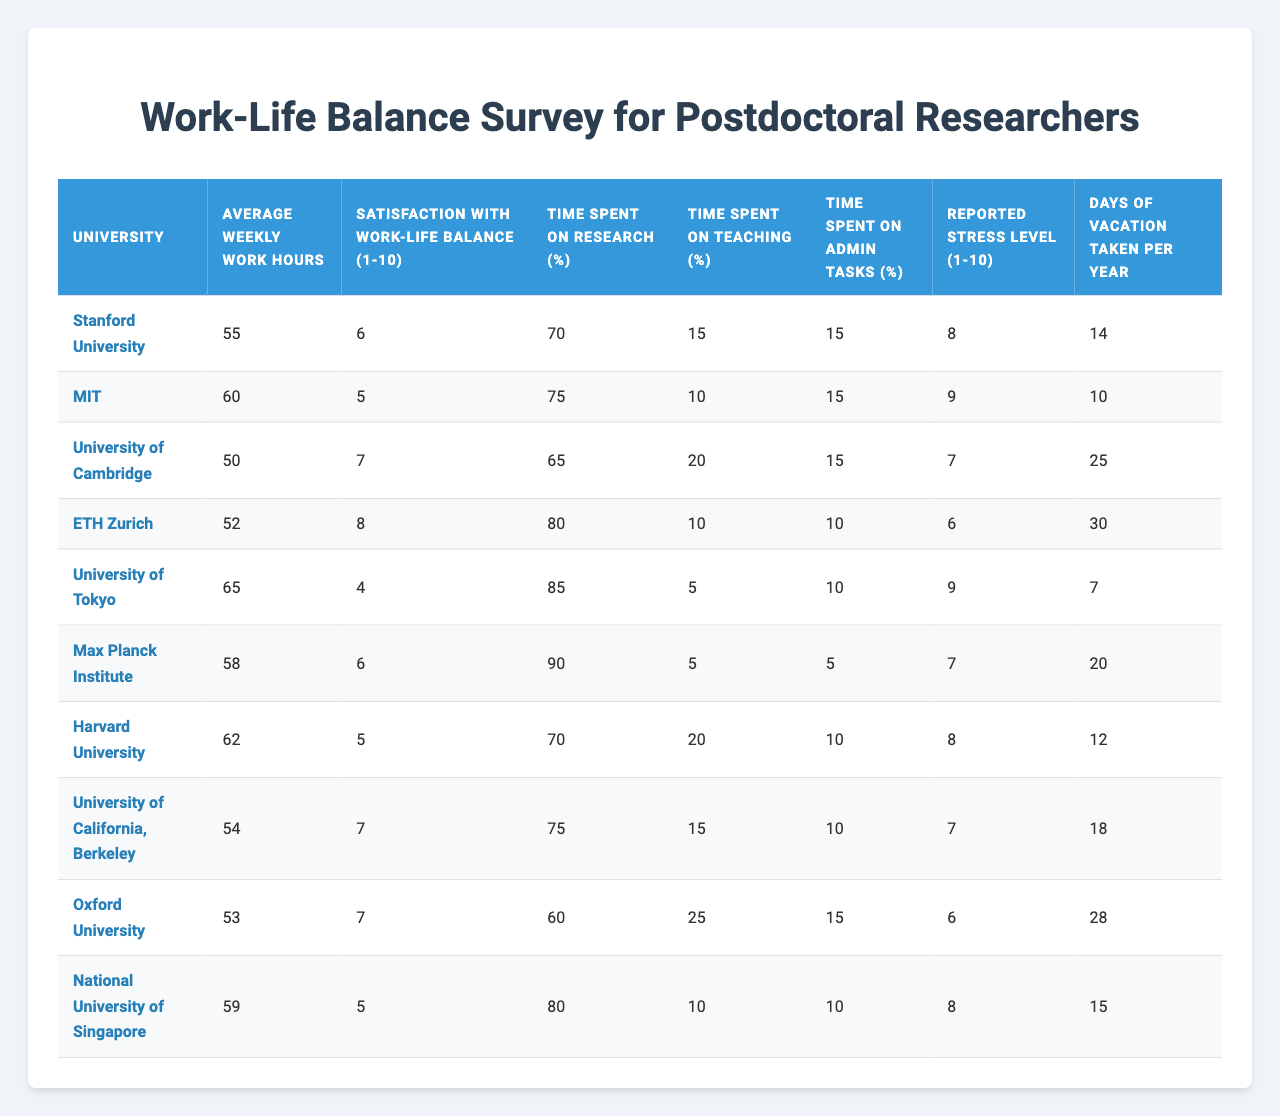What is the average weekly work hours for postdoctoral researchers at MIT? The table shows the value for "Average Weekly Work Hours" specifically for MIT, which is 60 hours.
Answer: 60 Which university reported the highest satisfaction with work-life balance? By examining the "Satisfaction with Work-Life Balance" column, I can see that ETH Zurich has the highest score of 8.
Answer: ETH Zurich How many days of vacation did postdoctoral researchers at the University of Cambridge take on average? The table lists the "Days of Vacation Taken per Year" for the University of Cambridge, which is 25 days.
Answer: 25 What is the reported stress level for postdoctoral researchers at the University of Tokyo? The "Reported Stress Level" for the University of Tokyo is shown in the table as 9.
Answer: 9 What is the average reported stress level across all universities listed? To find the average, I'll add up all reported stress levels: (8 + 9 + 7 + 6 + 9 + 7 + 8 + 7 + 6 + 8) = 79. There are 10 universities, so the average is 79/10 = 7.9.
Answer: 7.9 Is the time spent on teaching higher at Stanford University than at the University of California, Berkeley? I can compare the "Time Spent on Teaching (%)" values between Stanford (15%) and Berkeley (15%) and see that they are equal.
Answer: No Which university has the lowest percentage of time spent on research? The table indicates that Oxford University has the lowest percentage of time spent on research at 60%.
Answer: Oxford University What is the difference in average weekly work hours between the University of Tokyo and the Max Planck Institute? The average weekly work hours for the University of Tokyo is 65, and for Max Planck Institute, it's 58. The difference is 65 - 58 = 7 hours.
Answer: 7 At which university do postdoctoral researchers spend the least time on administrative tasks? By examining the "Time Spent on Admin Tasks (%)" column, I find that the Max Planck Institute has the lowest value at 5%.
Answer: Max Planck Institute What is the total number of vacation days taken by postdoctoral researchers at all universities combined? I'll add up the "Days of Vacation Taken per Year" for all universities: (14 + 10 + 25 + 30 + 7 + 20 + 12 + 18 + 28 + 15) =  12 + 16 + 14 + 16 + 10 + 30 + 30 = 28 + 60 =  10 = 168 days.
Answer: 168 